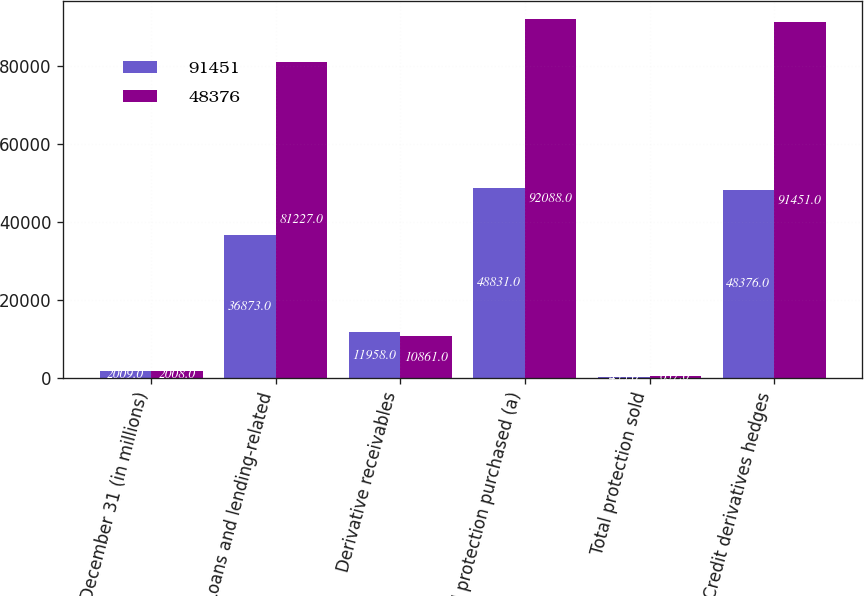Convert chart. <chart><loc_0><loc_0><loc_500><loc_500><stacked_bar_chart><ecel><fcel>December 31 (in millions)<fcel>Loans and lending-related<fcel>Derivative receivables<fcel>Total protection purchased (a)<fcel>Total protection sold<fcel>Credit derivatives hedges<nl><fcel>91451<fcel>2009<fcel>36873<fcel>11958<fcel>48831<fcel>455<fcel>48376<nl><fcel>48376<fcel>2008<fcel>81227<fcel>10861<fcel>92088<fcel>637<fcel>91451<nl></chart> 